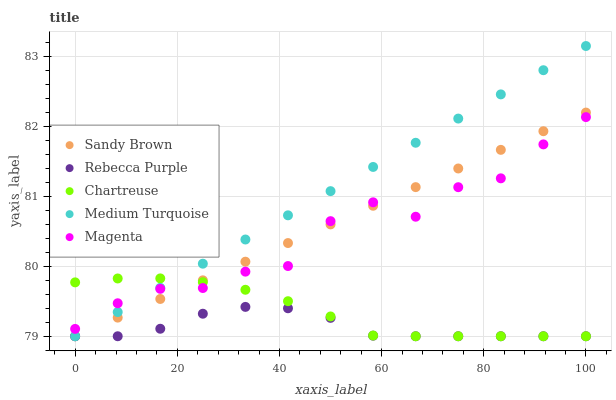Does Rebecca Purple have the minimum area under the curve?
Answer yes or no. Yes. Does Medium Turquoise have the maximum area under the curve?
Answer yes or no. Yes. Does Chartreuse have the minimum area under the curve?
Answer yes or no. No. Does Chartreuse have the maximum area under the curve?
Answer yes or no. No. Is Medium Turquoise the smoothest?
Answer yes or no. Yes. Is Magenta the roughest?
Answer yes or no. Yes. Is Chartreuse the smoothest?
Answer yes or no. No. Is Chartreuse the roughest?
Answer yes or no. No. Does Chartreuse have the lowest value?
Answer yes or no. Yes. Does Medium Turquoise have the highest value?
Answer yes or no. Yes. Does Chartreuse have the highest value?
Answer yes or no. No. Is Rebecca Purple less than Magenta?
Answer yes or no. Yes. Is Magenta greater than Rebecca Purple?
Answer yes or no. Yes. Does Chartreuse intersect Magenta?
Answer yes or no. Yes. Is Chartreuse less than Magenta?
Answer yes or no. No. Is Chartreuse greater than Magenta?
Answer yes or no. No. Does Rebecca Purple intersect Magenta?
Answer yes or no. No. 